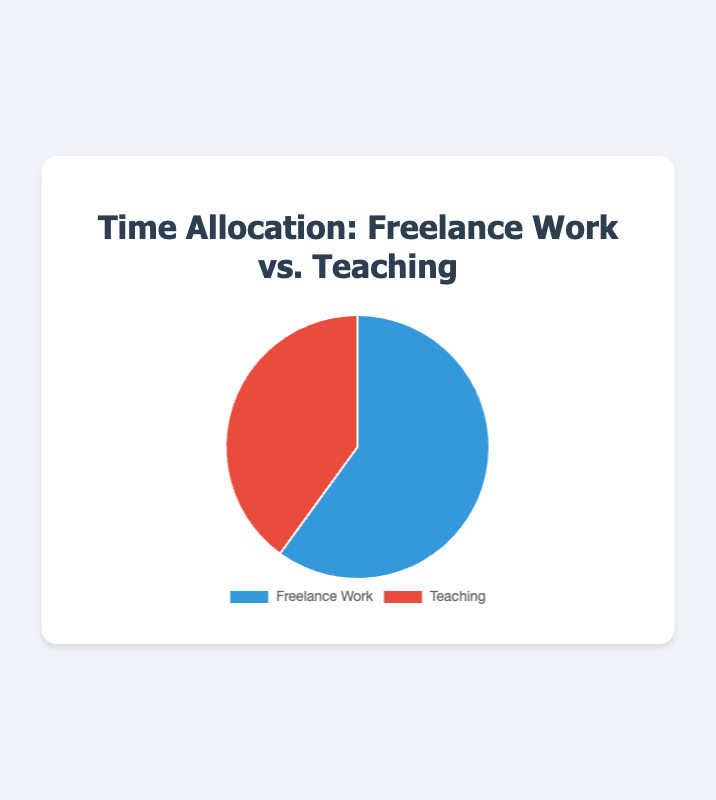What percentage of time is spent on Freelance Work? The pie chart shows two activities: Freelance Work and Teaching. The segment labeled 'Freelance Work' indicates a percentage of 60%.
Answer: 60% Which activity consumes less of your time? The pie chart segments are labeled 'Freelance Work' and 'Teaching'. The 'Teaching' segment, at 40%, is smaller compared to the 'Freelance Work' segment, at 60%.
Answer: Teaching What is the time difference between Freelance Work and Teaching? The percentages for Freelance Work and Teaching are 60% and 40%, respectively. The difference is obtained by subtracting 40% from 60%.
Answer: 20% How would you describe the color used for Teaching in the pie chart? The color coding for the pie chart shows the 'Teaching' segment in red.
Answer: Red Is the time spent on Freelance Work exactly half of your total time? The 'Freelance Work' segment shows 60%, which is more than half of the total time (50%).
Answer: No If you spend 10 hours working, how much time do you allocate to Freelance Work? Given Freelance Work is 60% of your time, multiply 10 hours by 0.6. That equals 6 hours.
Answer: 6 hours Which activity is represented by the blue segment? Observing the pie chart, the blue segment corresponds to the 'Freelance Work' activity.
Answer: Freelance Work If you added 20% more to the time spent on Teaching, what would be the new percentage? The current percentage for Teaching is 40%. Adding 20% of 40 (which is 8%) results in a new percentage of 48%.
Answer: 48% Compare the sizes of the segments for Freelance Work and Teaching. 'Freelance Work' occupies 60%, while 'Teaching' occupies 40%. Therefore, the Freelance Work segment is larger.
Answer: Freelance Work is larger What total percentage of time do these activities account for together? The total time for both activities is 60% for Freelance Work and 40% for Teaching. Summing these gives 100%.
Answer: 100% 